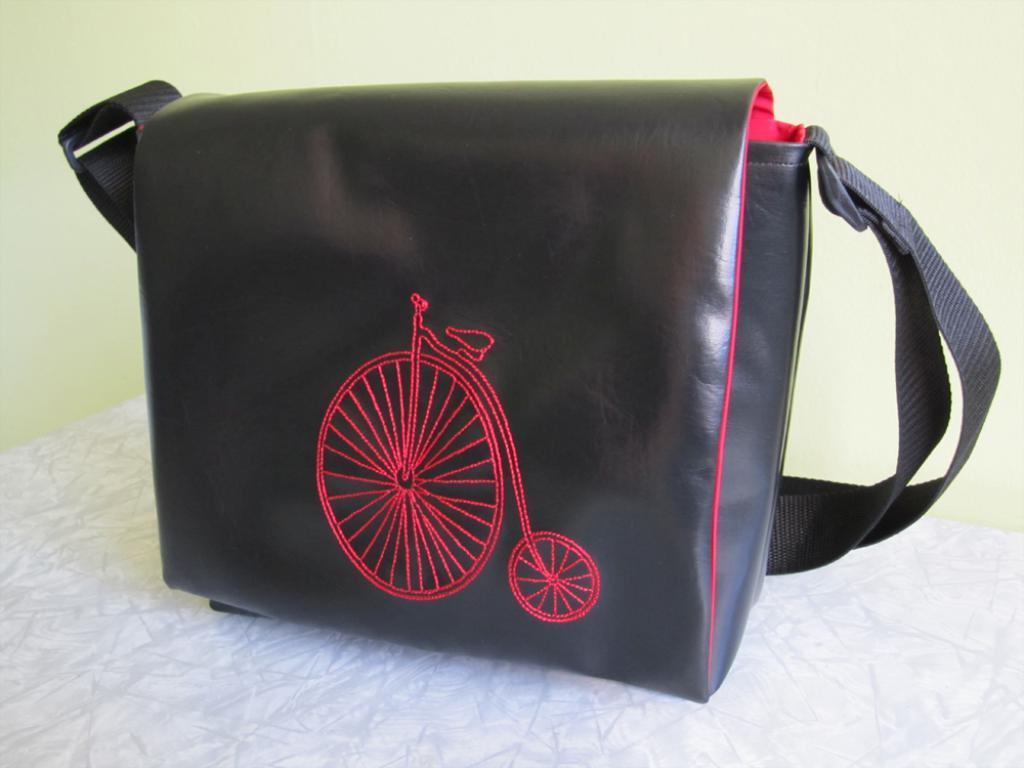What object can be seen in the image? There is a bag in the image. What is the color of the bag? The bag is black in color. Where is the bag located in the image? The bag is placed on a table. What can be seen in the background of the image? There is a wall in the background of the image. Can you see a crown on the bag in the image? There is no crown present on the bag in the image. How many cats are sitting on the table next to the bag? There are no cats present in the image; it only features a bag on a table with a wall in the background. 